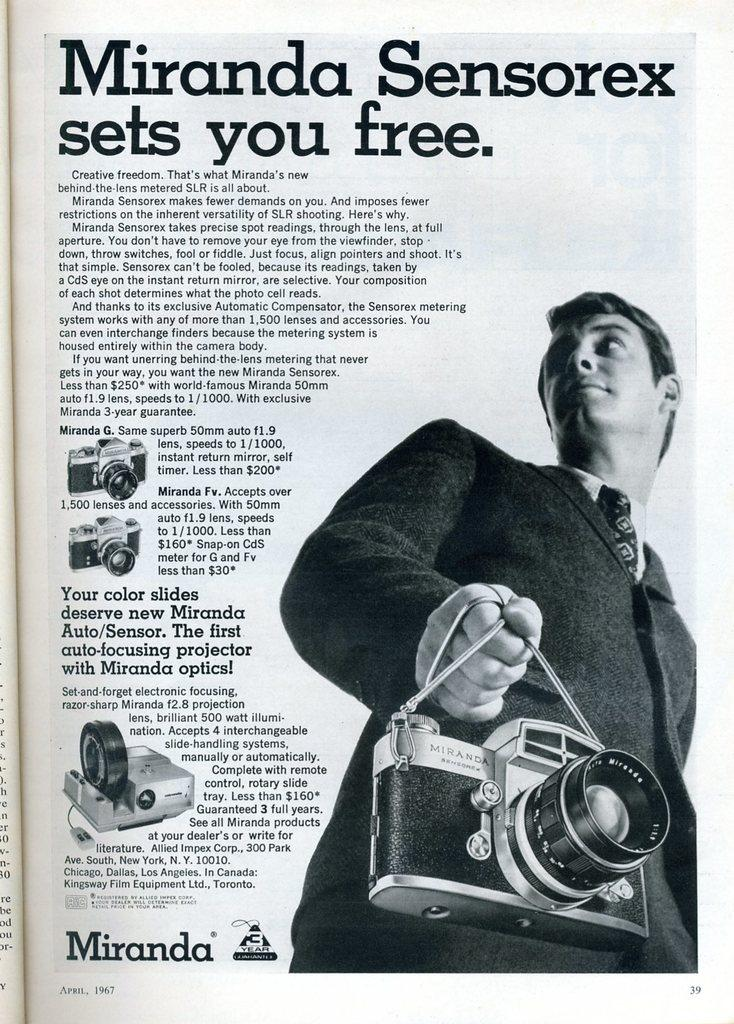What is depicted on the paper in the image? There is a picture of a man holding a camera on the paper, along with words and numbers. What else can be seen on the paper besides the picture of the man holding a camera? There are pictures of cameras on the paper. What type of crack is visible on the paper in the image? There is no crack visible on the paper in the image. What kind of coil is present on the paper in the image? There is no coil present on the paper in the image. 